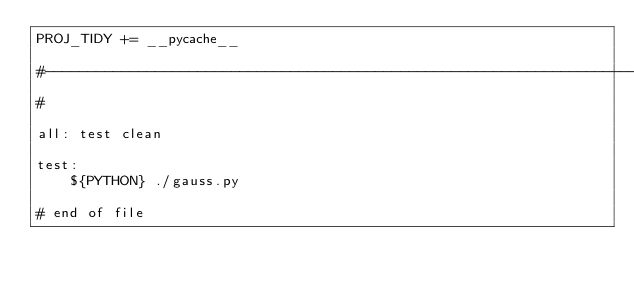Convert code to text. <code><loc_0><loc_0><loc_500><loc_500><_ObjectiveC_>PROJ_TIDY += __pycache__

#--------------------------------------------------------------------------
#

all: test clean

test:
	${PYTHON} ./gauss.py

# end of file
</code> 